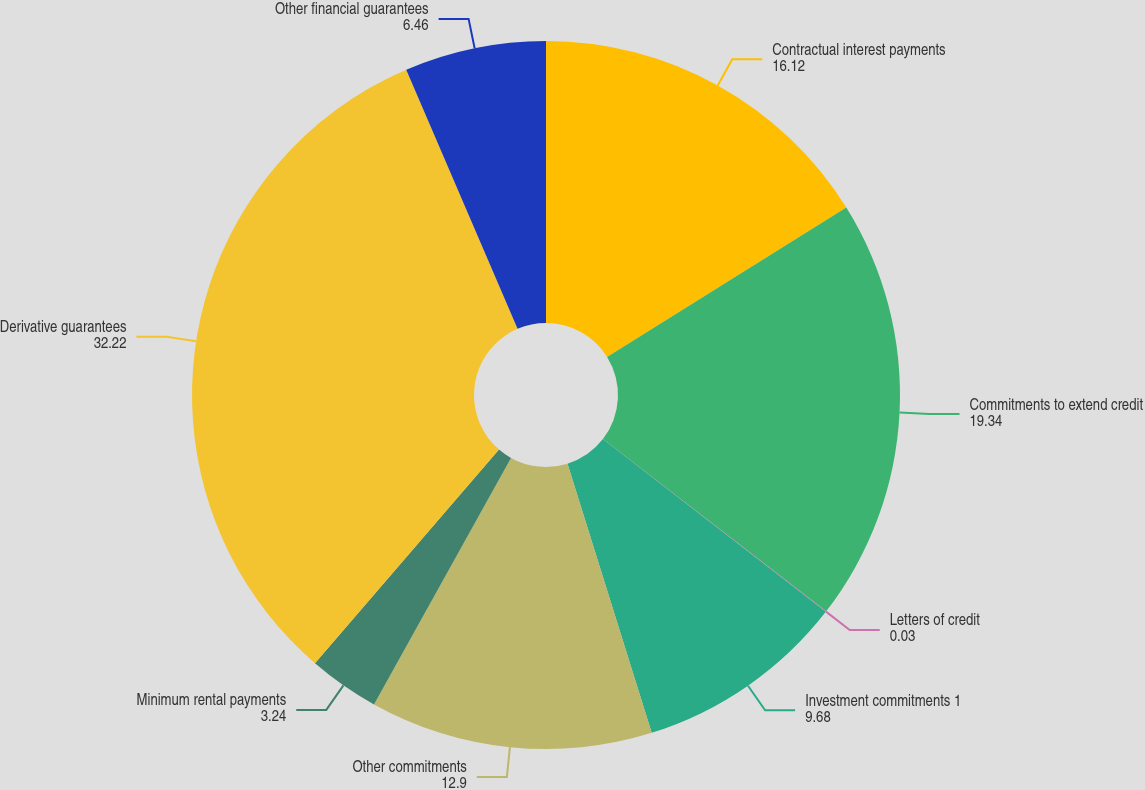Convert chart. <chart><loc_0><loc_0><loc_500><loc_500><pie_chart><fcel>Contractual interest payments<fcel>Commitments to extend credit<fcel>Letters of credit<fcel>Investment commitments 1<fcel>Other commitments<fcel>Minimum rental payments<fcel>Derivative guarantees<fcel>Other financial guarantees<nl><fcel>16.12%<fcel>19.34%<fcel>0.03%<fcel>9.68%<fcel>12.9%<fcel>3.24%<fcel>32.22%<fcel>6.46%<nl></chart> 